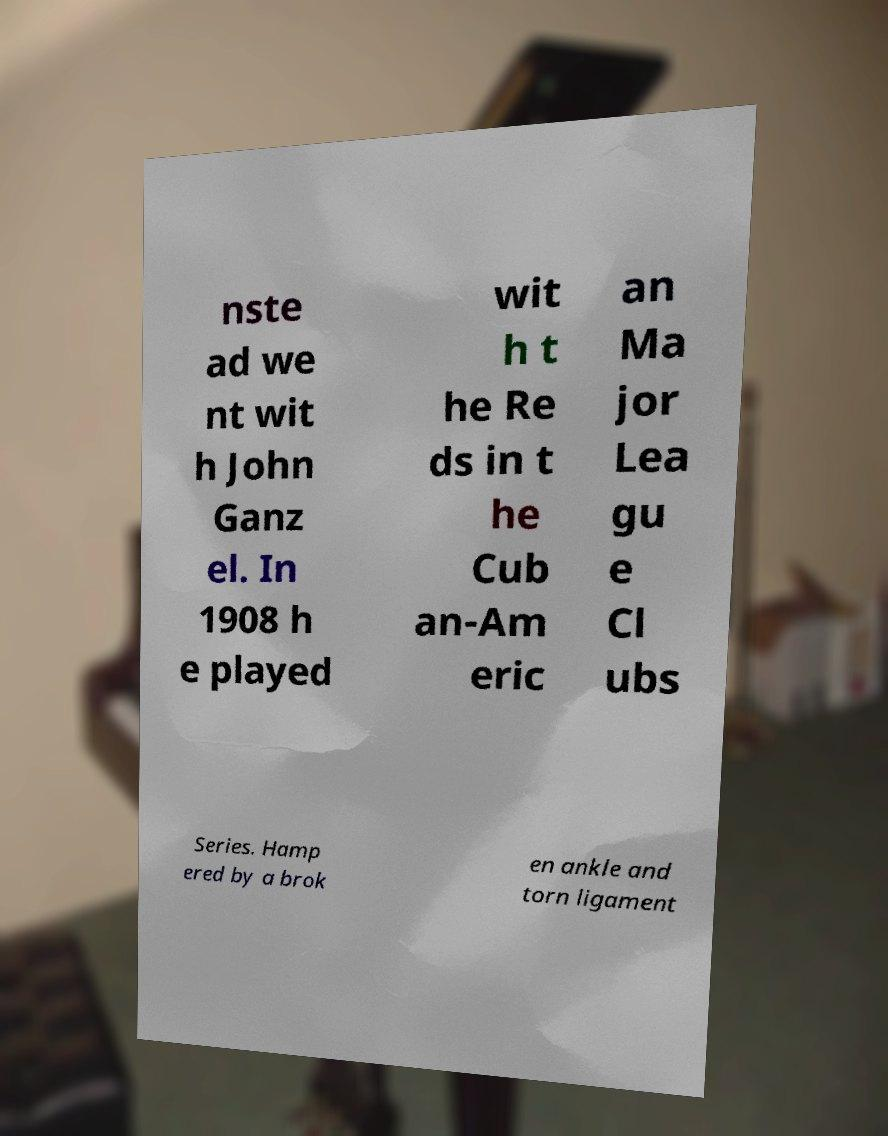Could you assist in decoding the text presented in this image and type it out clearly? nste ad we nt wit h John Ganz el. In 1908 h e played wit h t he Re ds in t he Cub an-Am eric an Ma jor Lea gu e Cl ubs Series. Hamp ered by a brok en ankle and torn ligament 